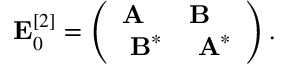Convert formula to latex. <formula><loc_0><loc_0><loc_500><loc_500>\begin{array} { r } { E _ { 0 } ^ { [ 2 ] } = \left ( \begin{array} { l l } { A } & { B } \\ { B ^ { * } } & { A ^ { * } } \end{array} \right ) . } \end{array}</formula> 